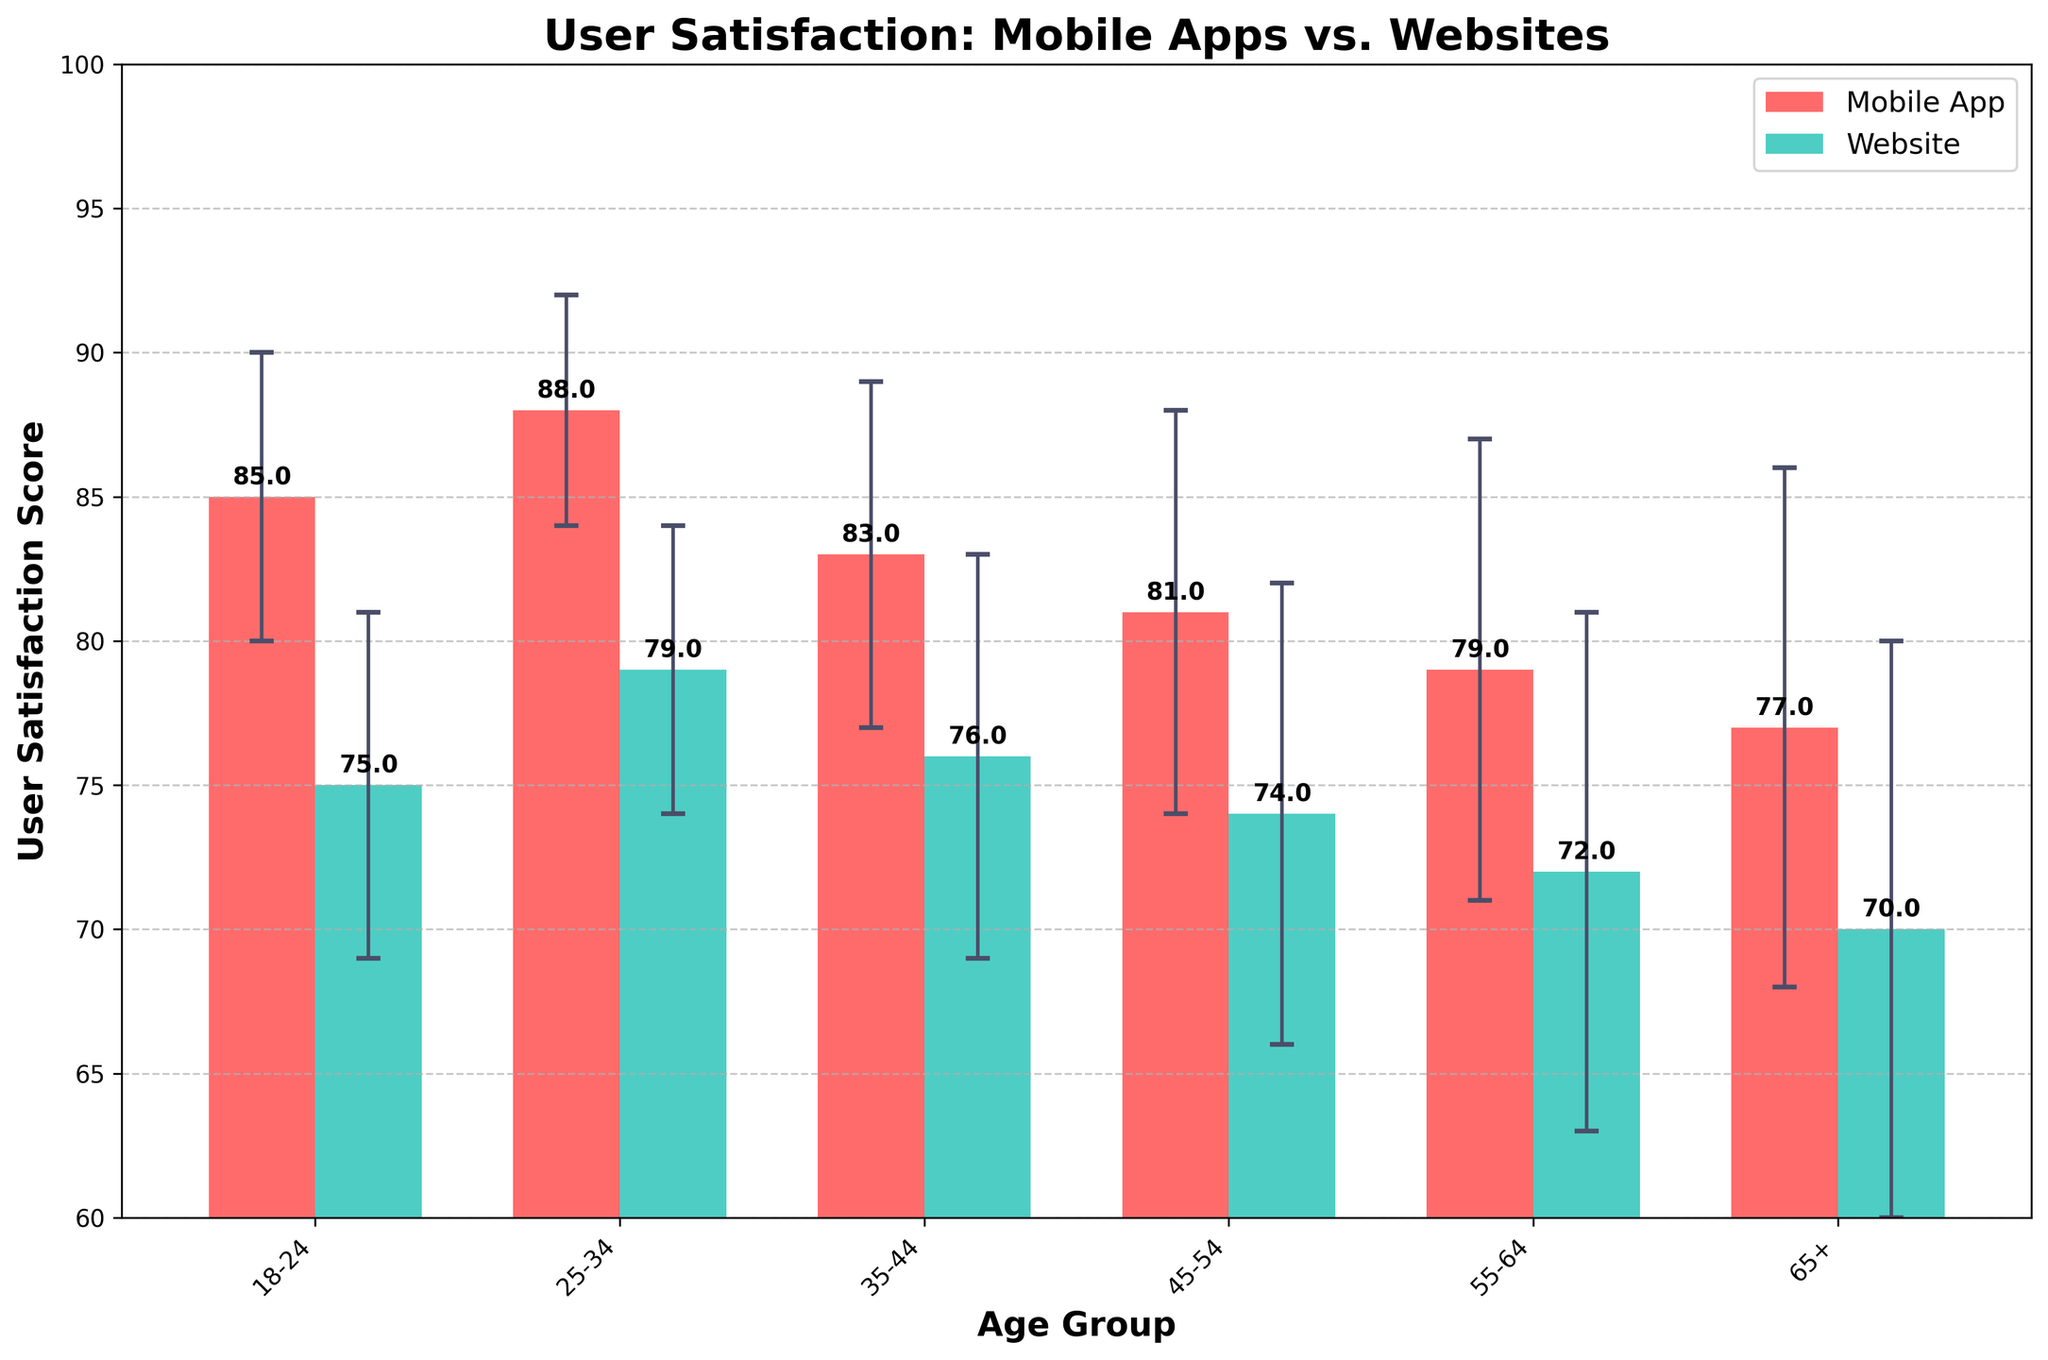What are the two platforms compared in the figure? The title indicates that the figure compares user satisfaction scores between Mobile Apps and Websites.
Answer: Mobile Apps and Websites What is the highest user satisfaction score, and which age group and platform does it belong to? The highest score, observed on the y-axis, is for Mobile Apps in the 25-34 age group, which is 88.
Answer: 88, 25-34, Mobile App What is the lowest user satisfaction score, and for which age group and platform? The lowest score, seen on the y-axis, is for Websites in the 65+ age group, which is 70.
Answer: 70, 65+, Website For the 35-44 age group, which platform has a higher user satisfaction score, and by how much? By examining the bars for the 35-44 age group, Mobile Apps have a score of 83 while Websites have 76. The difference is 83 - 76.
Answer: Mobile App, 7 Which platform has consistently higher user satisfaction scores across all age groups? By comparing the bars for each age group, it is evident that Mobile Apps consistently have higher scores.
Answer: Mobile Apps What is the average user satisfaction score across all age groups for Mobile Apps? The scores for Mobile Apps across the age groups are 85, 88, 83, 81, 79, and 77. Summing them gives 493, and there are 6 age groups, so the average is 493 / 6.
Answer: 82.17 How do the error bars for Mobile Apps compare to those for Websites? The error bars represent standard deviations. In general, the error bars for Websites are larger across all age groups when compared to Mobile Apps.
Answer: Larger for Websites Which age group shows the smallest difference in user satisfaction scores between the two platforms, and what is that difference? By examining all age groups, the 18-24 group shows the smallest difference. Mobile Apps have a score of 85 and Websites have 75, resulting in a difference of 85 - 75.
Answer: 18-24, 10 In the 45-54 age group, how do the standard deviations for the two platforms compare? The error bars indicate the standard deviation for Mobile Apps is 7, and for Websites, it is 8.
Answer: Mobile Apps: 7, Websites: 8 